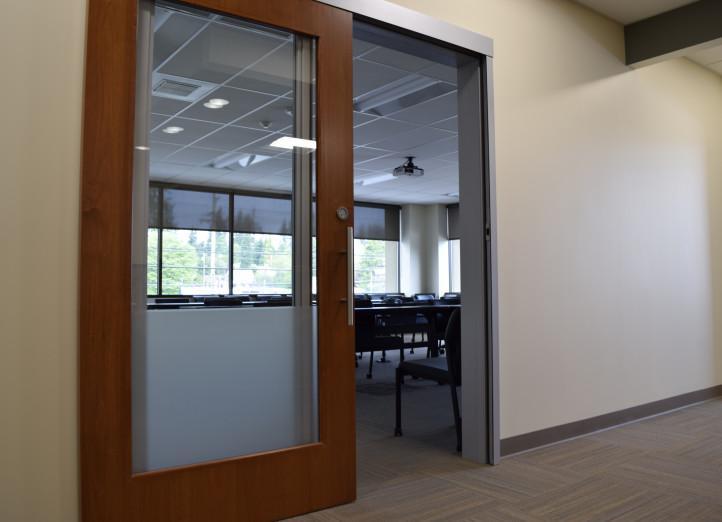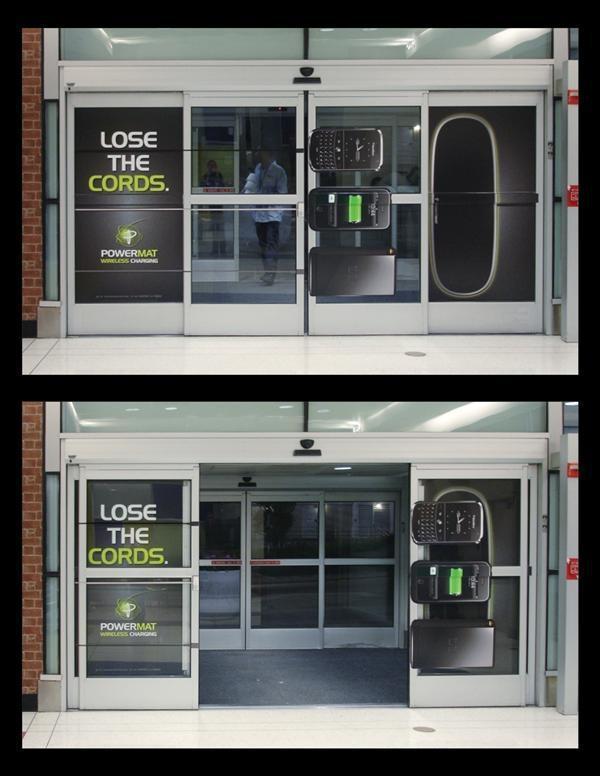The first image is the image on the left, the second image is the image on the right. Considering the images on both sides, is "One of the images is split; the same door is being shown both open, and closed." valid? Answer yes or no. Yes. 